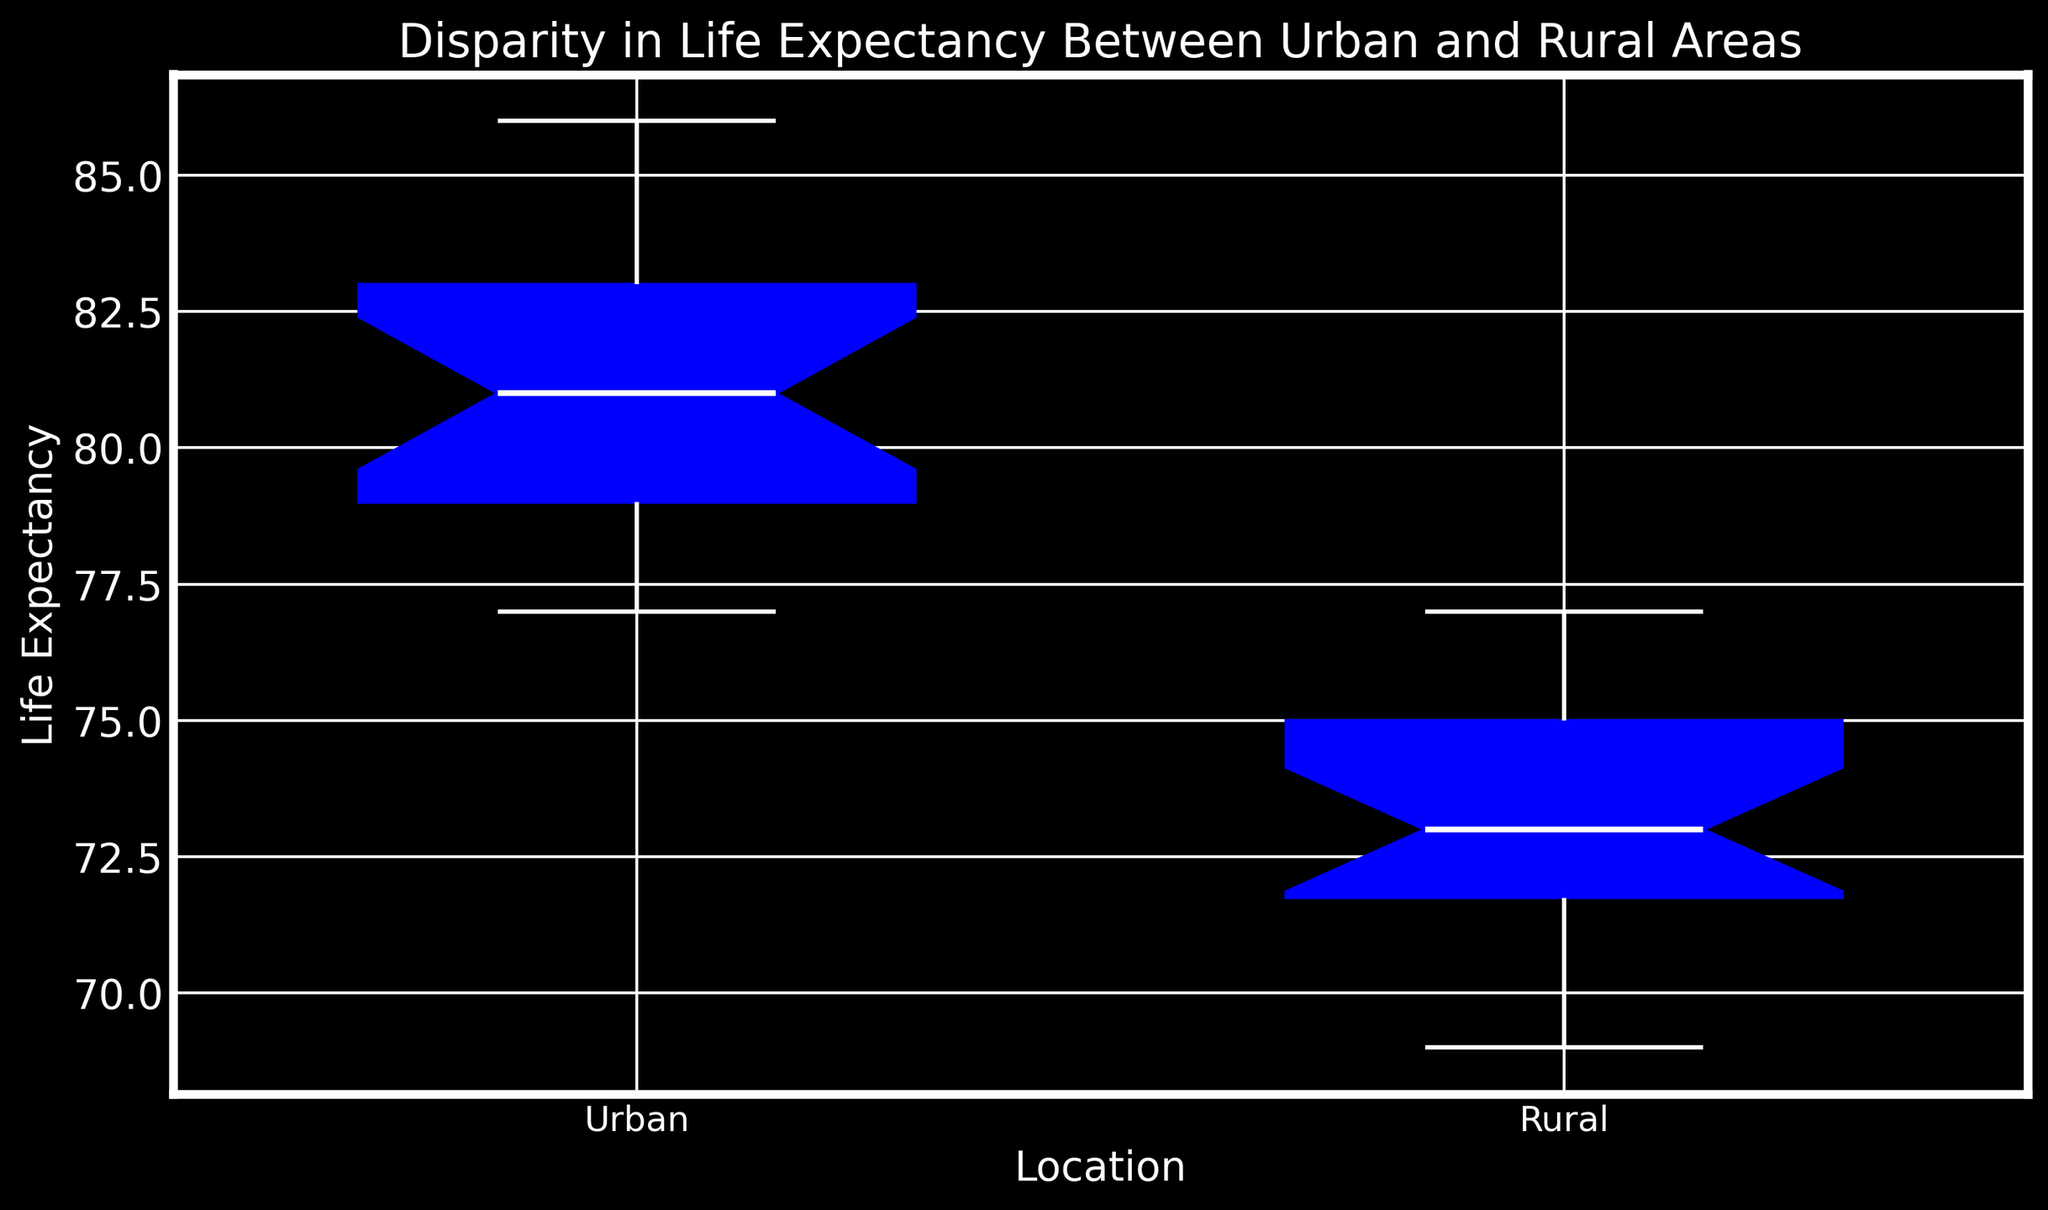What's the median life expectancy for Urban and Rural areas? The median is the middle value when the data points are ordered. For Urban, arrange life expectancies: 77, 78, 78, 79, 79, 79, 80, 80, 81, 81, 81, 82, 82, 82, 83, 83, 84, 85, 85, 86. The median is between 81 and 81, so it's 81. For Rural, arrange: 69, 70, 70, 71, 71, 72, 72, 72, 73, 73, 73, 74, 74, 74, 75, 75, 75, 76, 76, 77. The median is between 73 and 73, so it's 73.
Answer: Urban: 81, Rural: 73 Which area shows a higher range in life expectancy, Urban or Rural? The range is calculated by subtracting the minimum value from the maximum value. For Urban: maximum value is 86, minimum value is 77, so range = 86-77 = 9. For Rural: maximum value is 77, minimum value is 69, so range = 77-69 = 8. Urban has a higher range.
Answer: Urban What is the interquartile range (IQR) for Urban and Rural areas? The IQR is the difference between the third quartile (Q3) and the first quartile (Q1). For Urban: Q1 is 79, Q3 is 83, so IQR = 83-79 = 4. For Rural: Q1 is 71, Q3 is 75, so IQR = 75-71 = 4.
Answer: Urban: 4, Rural: 4 Are there any outliers in the Rural area life expectancy data? Outliers typically fall below Q1 - 1.5*IQR or above Q3 + 1.5*IQR. For Rural, Q1 = 71, Q3 = 75, IQR = 4. Bounds for outliers are below 71 - 1.5*4 = 65, and above 75 + 1.5*4 = 81. No life expectancy for the Rural area is outside these bounds, indicating no outliers.
Answer: No Which location has the higher median life expectancy? From the box plot, the median life expectancy is the line inside the box. The Urban area's median line is higher than that of the Rural area.
Answer: Urban In which location is the middle 50% of the data (the box area) more spread out? The spread of the middle 50% of data is represented by the height of the box. Both Urban and Rural have the same interquartile range (IQR), evident from the height of their boxes.
Answer: Neither, they are the same What is the main visual difference between the Urban and Rural boxes in the box plot? Visually, the Urban box appears to start and end at higher life expectancy values compared to the Rural box. This indicates that overall, Urban areas have higher life expectancy values.
Answer: Urban box starts and ends higher How does the median life expectancy in Rural areas compare to the lower quartile in Urban areas? The median life expectancy in Rural areas is 73, while the lower quartile (Q1) in Urban areas is 79. Comparing these, 73 (Rural median) is less than 79 (Urban Q1).
Answer: Less than What does the white line inside the boxes represent? The white line inside each box represents the median life expectancy for each location (Urban and Rural).
Answer: Median 